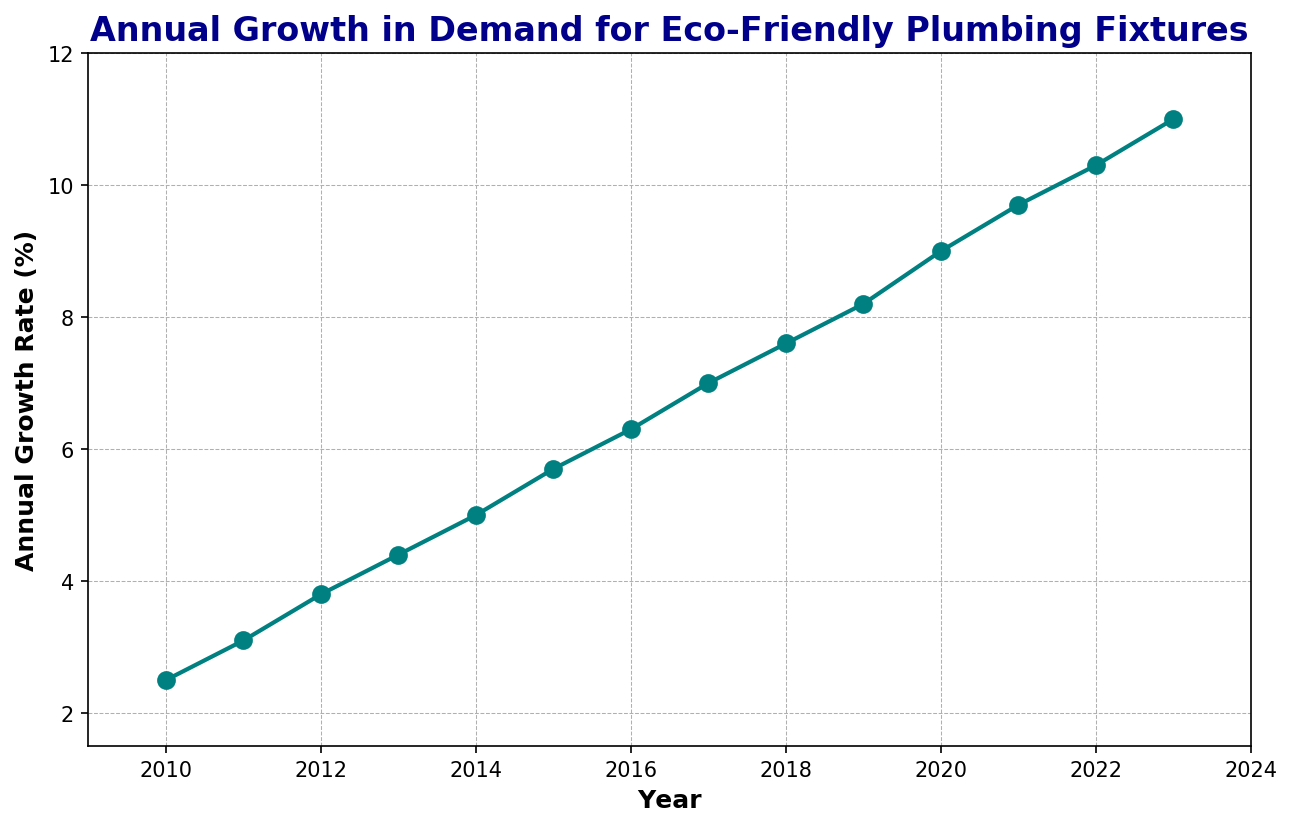What's the average annual growth rate from 2010 to 2023? To find the average annual growth rate, sum up all the growth rates from 2010 to 2023 and divide by the number of years. The sum is 99.6, and there are 14 years, so the average is 99.6/14 ≈ 7.11%.
Answer: 7.11% In which year did the annual growth rate first exceed 5%? The annual growth rate first exceeds 5% in 2014. Referring to the plot, the growth rate crosses the 5% mark exactly in 2014.
Answer: 2014 Which year experienced the highest annual growth rate? By looking at the plot, the highest data point is in 2023, where the growth rate reached 11.0%.
Answer: 2023 How much did the growth rate increase from 2010 to 2020? The growth rate in 2010 is 2.5%, and in 2020 it is 9.0%. The increase is calculated by subtracting the 2010 rate from the 2020 rate, which is 9.0% - 2.5% = 6.5%.
Answer: 6.5% Between which consecutive years was the growth rate increase the greatest? To find this, we need to compute the year-over-year changes and determine the maximum. The differences are: 0.6 (2010-2011), 0.7 (2011-2012), 0.6 (2012-2013), 0.6 (2013-2014), 0.7 (2014-2015), 0.6 (2015-2016), 0.7 (2016-2017), 0.6 (2017-2018), 0.6 (2018-2019), 0.8 (2019-2020), 0.7 (2020-2021), 0.6 (2021-2022), 0.7 (2022-2023). The greatest increase is 0.8 between 2019 and 2020.
Answer: 2019-2020 Are there any years where the growth rate was exactly 5%? By inspecting the plot, the growth rate is exactly 5.0% in 2014.
Answer: 2014 How many years did it take for the annual growth rate to double from the initial rate of 2.5%? Starting from 2.5% in 2010, doubling the rate would mean reaching 5%. It took until 2014, so it took 4 years to double from the initial rate.
Answer: 4 years What was the growth rate difference between the first and last year in the chart? The growth rate in 2010 was 2.5%, and in 2023 it was 11.0%. The difference is 11.0% - 2.5% = 8.5%.
Answer: 8.5% Which year had a growth rate closest to the average growth rate from 2010 to 2023? The average growth rate is approximately 7.11%. By inspecting the plot, 2017 had a growth rate of 7.0%, which is closest to the average.
Answer: 2017 